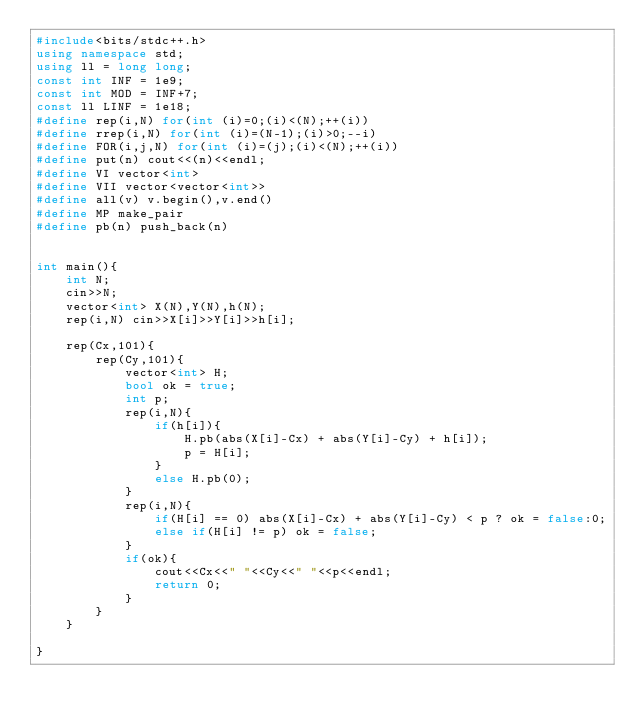<code> <loc_0><loc_0><loc_500><loc_500><_C++_>#include<bits/stdc++.h>
using namespace std;
using ll = long long;
const int INF = 1e9;
const int MOD = INF+7;
const ll LINF = 1e18;
#define rep(i,N) for(int (i)=0;(i)<(N);++(i))
#define rrep(i,N) for(int (i)=(N-1);(i)>0;--i)
#define FOR(i,j,N) for(int (i)=(j);(i)<(N);++(i))
#define put(n) cout<<(n)<<endl;
#define VI vector<int>
#define VII vector<vector<int>>
#define all(v) v.begin(),v.end()
#define MP make_pair
#define pb(n) push_back(n)


int main(){
    int N;
    cin>>N;
    vector<int> X(N),Y(N),h(N);
    rep(i,N) cin>>X[i]>>Y[i]>>h[i];

    rep(Cx,101){
        rep(Cy,101){
            vector<int> H;
            bool ok = true;
            int p;
            rep(i,N){
                if(h[i]){
                    H.pb(abs(X[i]-Cx) + abs(Y[i]-Cy) + h[i]);
                    p = H[i];
                }
                else H.pb(0);   
            }
            rep(i,N){
                if(H[i] == 0) abs(X[i]-Cx) + abs(Y[i]-Cy) < p ? ok = false:0;
                else if(H[i] != p) ok = false; 
            }
            if(ok){
                cout<<Cx<<" "<<Cy<<" "<<p<<endl;
                return 0;
            }
        }
    }

}</code> 